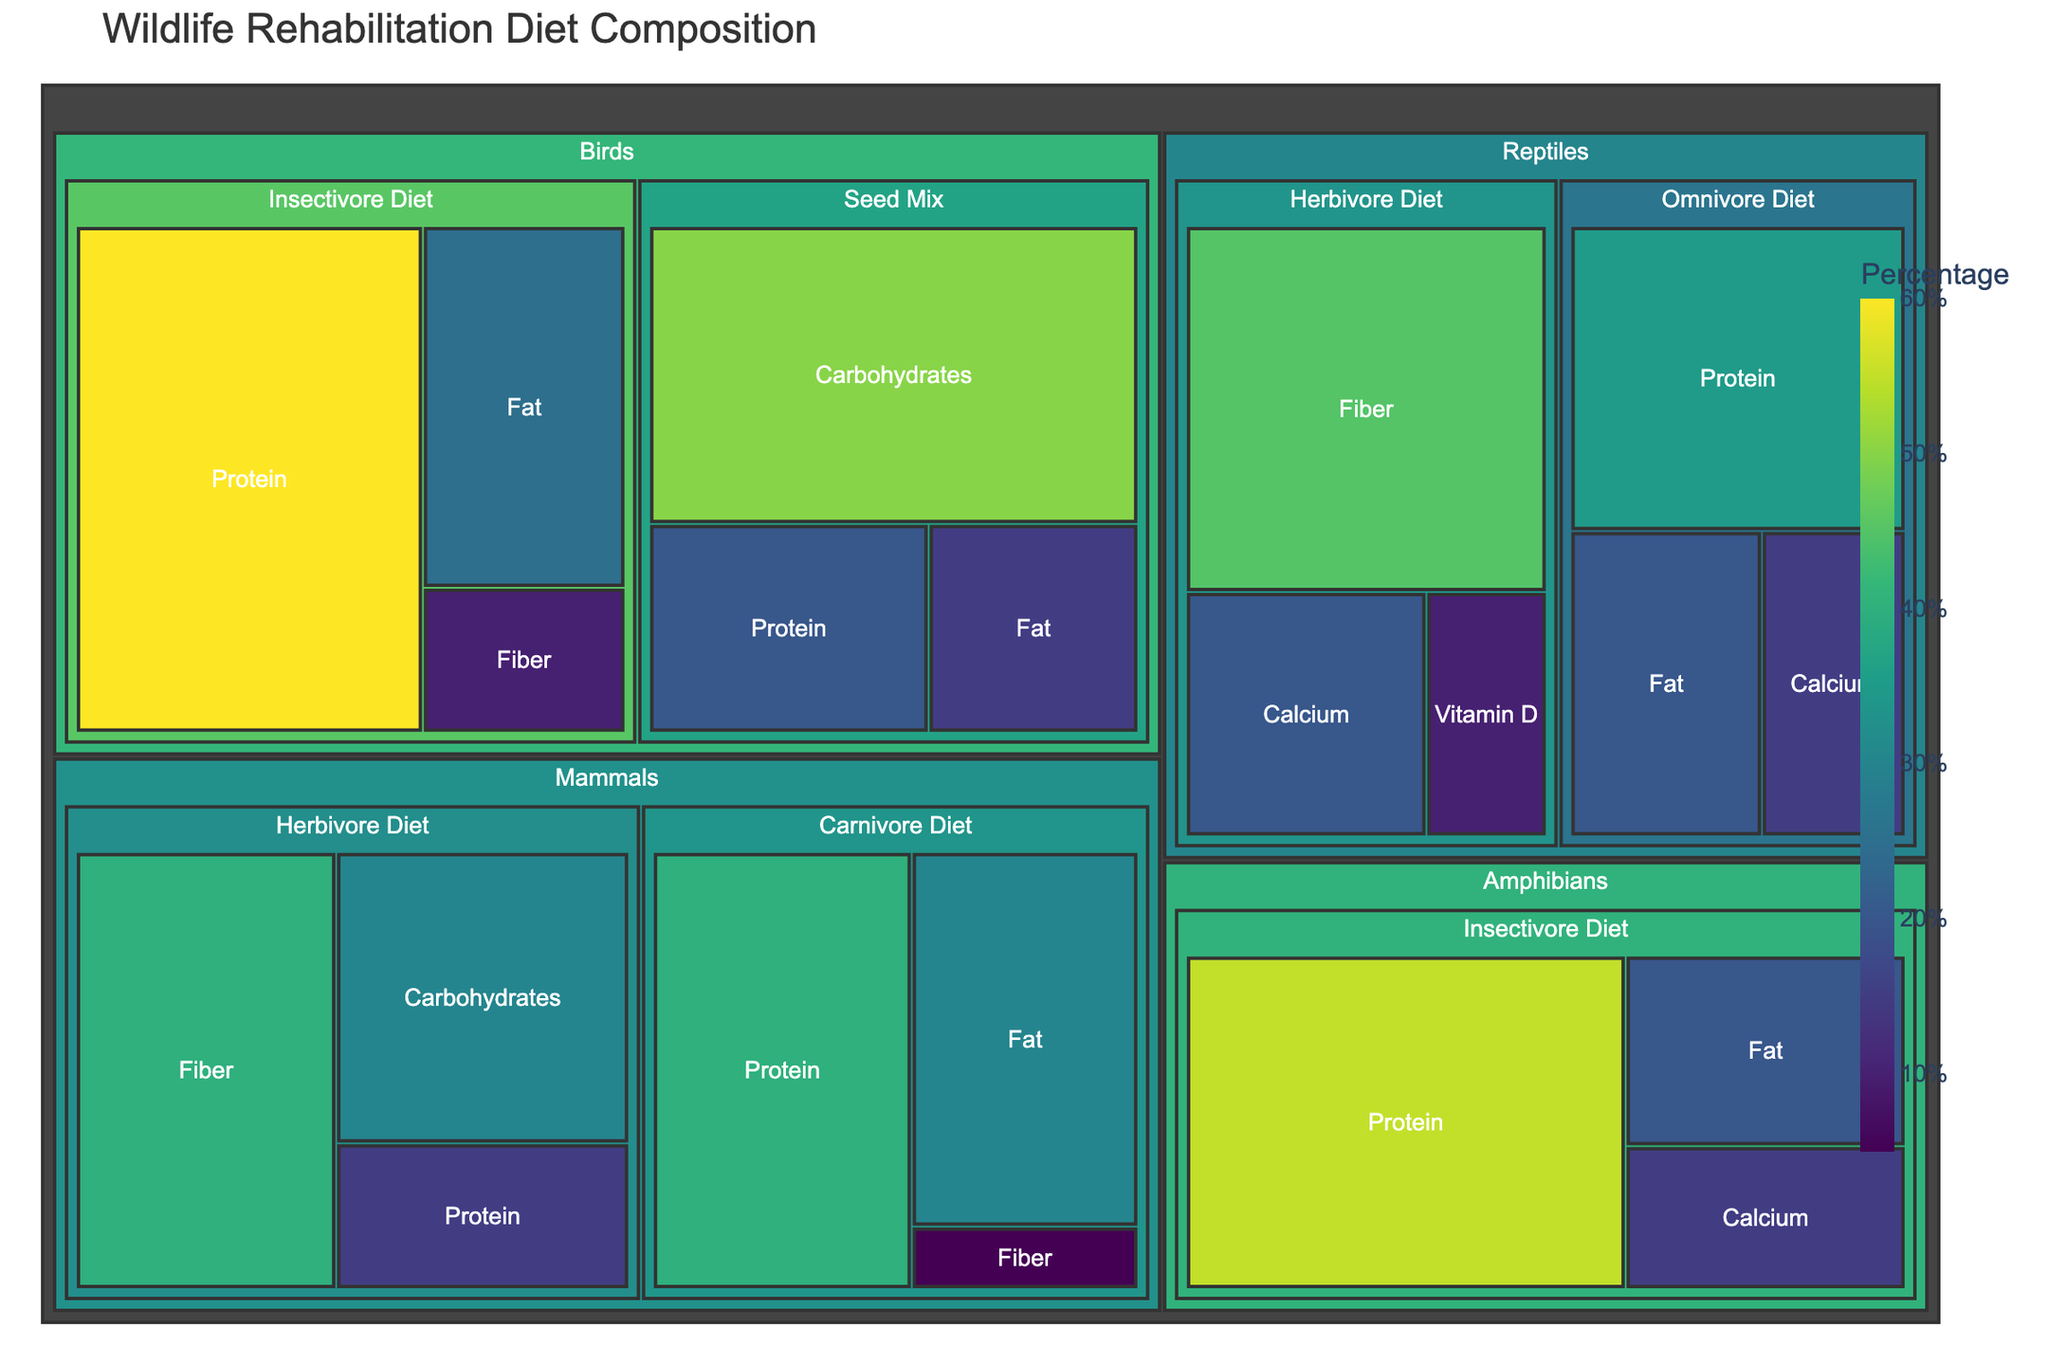What is the title of the treemap? Look at the top of the figure where the title is displayed.
Answer: Wildlife Rehabilitation Diet Composition Which animal group has the highest percentage of fiber in its diet? In the treemap, locate all the animal groups and their diet components focusing on the nutritional component "Fiber". Compare the values of fiber across the different groups.
Answer: Reptiles (Herbivore Diet - 45%) What is the total percentage of protein content for the diets of mammals? Identify all the diet components under "Mammals" and sum up their protein values: Carnivore Diet (40%) + Herbivore Diet (15%)
Answer: 55% Between birds and reptiles, which group's diet contains a higher percentage of fat in the Insectivore Diet? Locate both birds and reptiles in the treemap, then identify the fat values under the Insectivore Diet for each: Birds (25%) vs. Reptiles (No Insectivore Diet shown, so assume 0%).
Answer: Birds (25%) Which nutritional component has the largest single percentage value among the mammal's diets? Focus on the mammal group and observe the diet components with their respective percentages, identify the highest single percentage value.
Answer: Fiber (Herbivore Diet - 40%) What is the combined percentage of calcium and vitamin D for the reptiles' herbivore diet? Locate the Reptiles' Herbivore Diet and add the percentages of Calcium (20%) and Vitamin D (10%).
Answer: 30% Which diet component has the highest protein percentage in the bird group? In the bird group, compare the percentages of protein in both Seed Mix and Insectivore Diets.
Answer: Insectivore Diet (60%) How does the protein percentage in amphibians' diet compare to the protein percentage in reptiles' omnivore diet? Identify the protein percentage in amphibians' (Insectivore Diet - 55%) and reptiles' omnivore diet (35%), then compare them.
Answer: Higher in amphibians (55%) What is the overall percentage of carbohydrates in birds' diets? Add the carbohydrate percentages from the Seed Mix (50%), then check if any other diet for birds has carbohydrates included.
Answer: 50% What is the largest nutritional component by value in the reptiles' diet? Examine the nutritional components for reptiles across both Omnivore and Herbivore diets, and identify the largest single value.
Answer: Fiber (Herbivore Diet - 45%) 